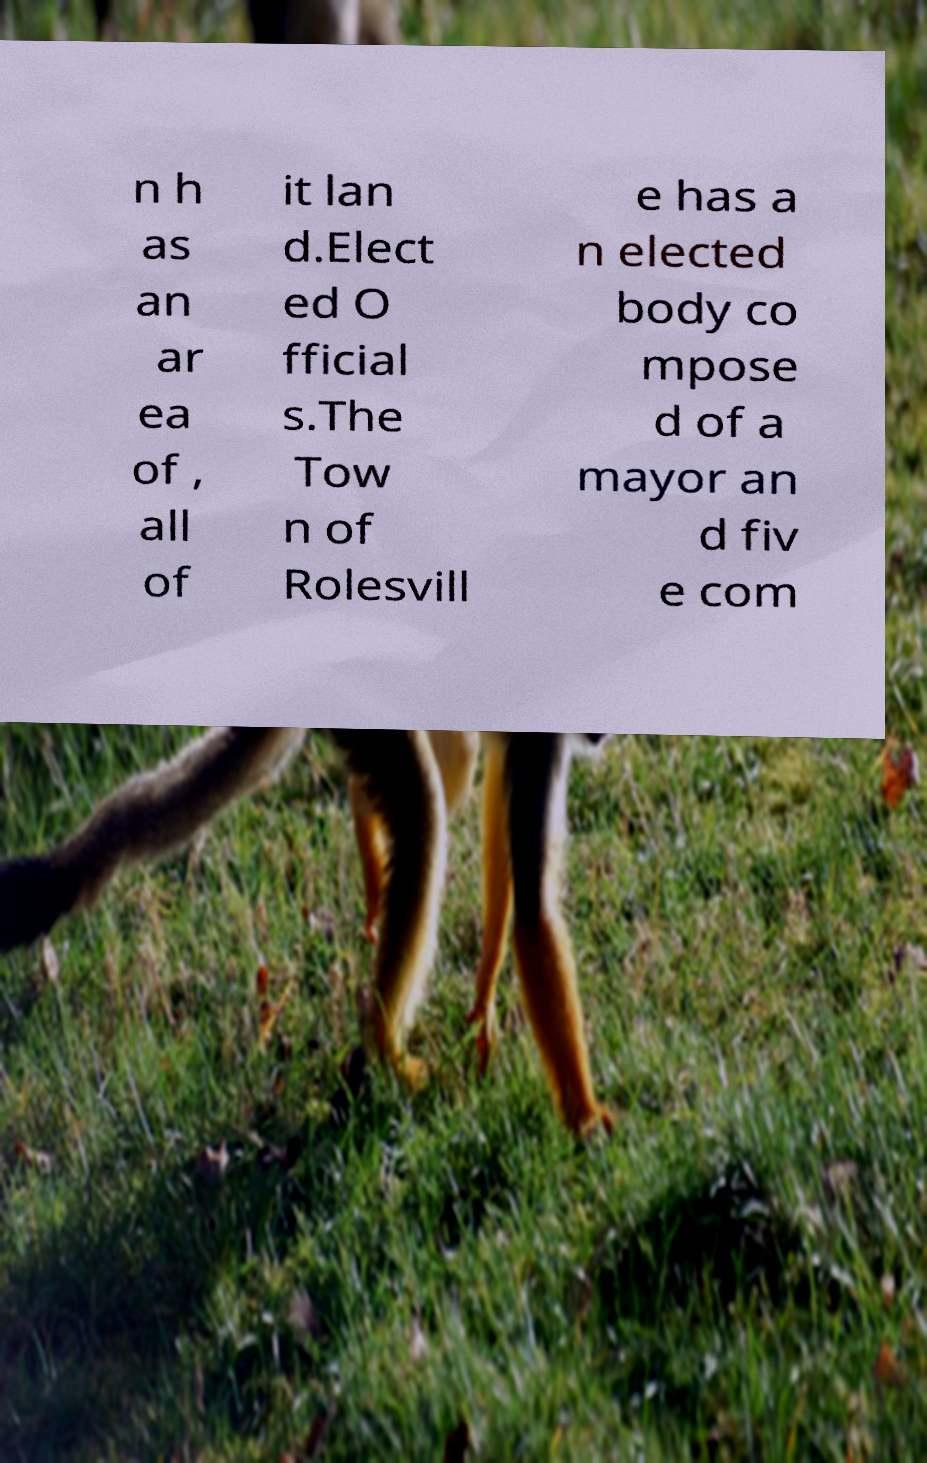Could you extract and type out the text from this image? n h as an ar ea of , all of it lan d.Elect ed O fficial s.The Tow n of Rolesvill e has a n elected body co mpose d of a mayor an d fiv e com 